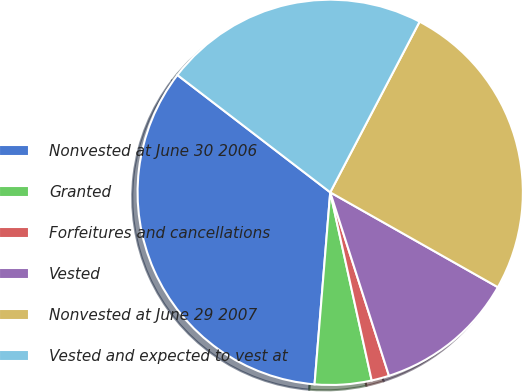<chart> <loc_0><loc_0><loc_500><loc_500><pie_chart><fcel>Nonvested at June 30 2006<fcel>Granted<fcel>Forfeitures and cancellations<fcel>Vested<fcel>Nonvested at June 29 2007<fcel>Vested and expected to vest at<nl><fcel>34.12%<fcel>4.75%<fcel>1.48%<fcel>11.87%<fcel>25.52%<fcel>22.26%<nl></chart> 